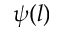Convert formula to latex. <formula><loc_0><loc_0><loc_500><loc_500>\psi ( l )</formula> 